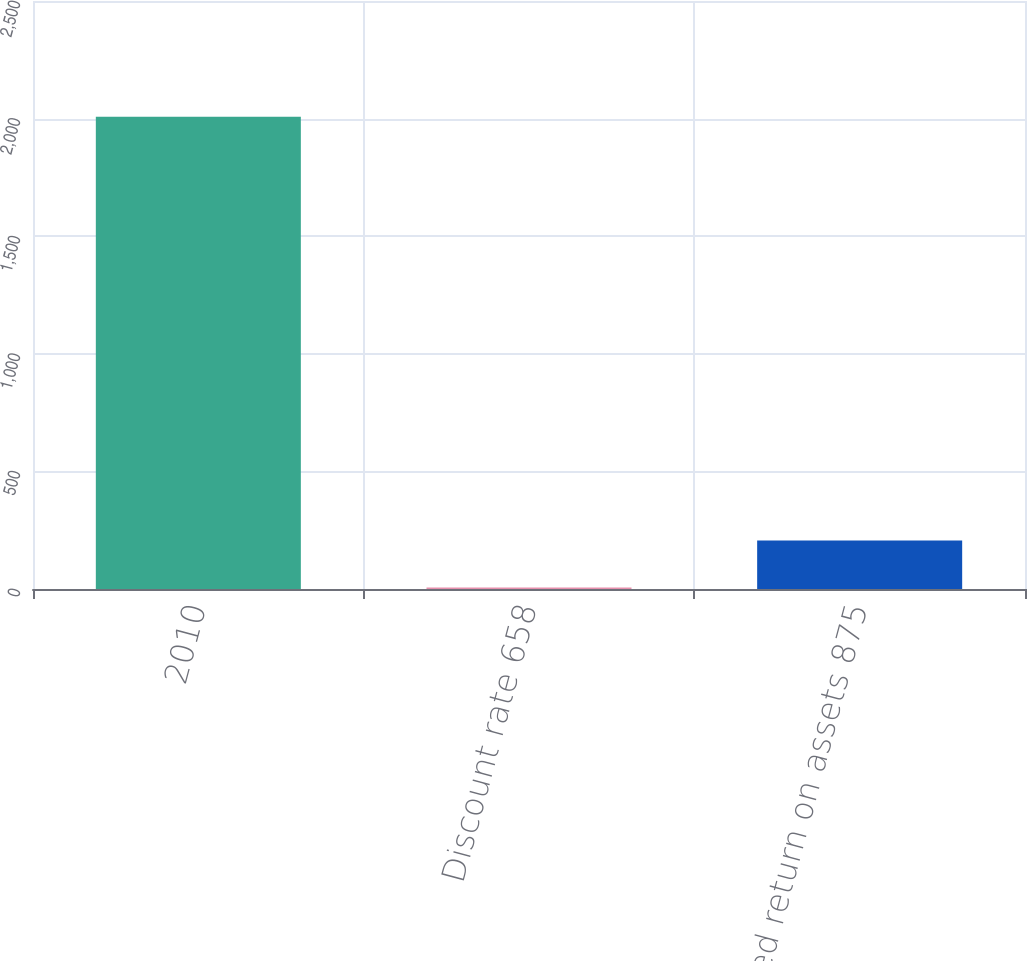<chart> <loc_0><loc_0><loc_500><loc_500><bar_chart><fcel>2010<fcel>Discount rate 658<fcel>Expected return on assets 875<nl><fcel>2008<fcel>6.47<fcel>206.62<nl></chart> 